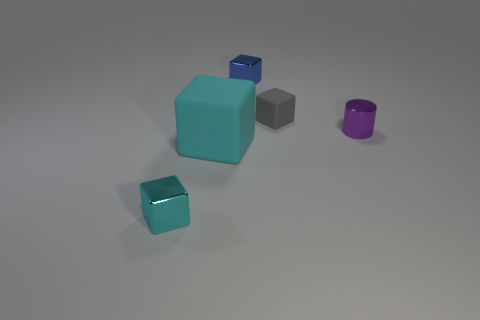Add 2 blocks. How many objects exist? 7 Subtract all cubes. How many objects are left? 1 Add 4 cubes. How many cubes are left? 8 Add 1 small red metal objects. How many small red metal objects exist? 1 Subtract 0 green spheres. How many objects are left? 5 Subtract all cyan objects. Subtract all small blue blocks. How many objects are left? 2 